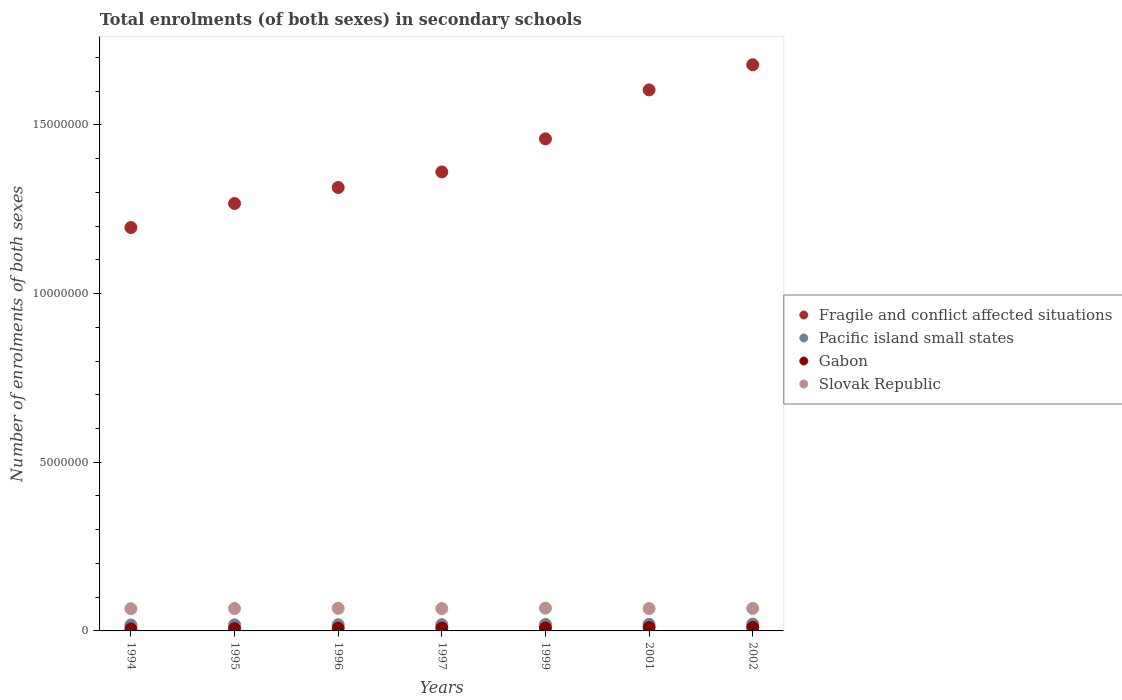What is the number of enrolments in secondary schools in Gabon in 1999?
Make the answer very short. 8.65e+04. Across all years, what is the maximum number of enrolments in secondary schools in Pacific island small states?
Your answer should be very brief. 2.03e+05. Across all years, what is the minimum number of enrolments in secondary schools in Gabon?
Offer a very short reply. 5.94e+04. In which year was the number of enrolments in secondary schools in Gabon maximum?
Keep it short and to the point. 2002. In which year was the number of enrolments in secondary schools in Slovak Republic minimum?
Offer a very short reply. 1994. What is the total number of enrolments in secondary schools in Pacific island small states in the graph?
Your response must be concise. 1.32e+06. What is the difference between the number of enrolments in secondary schools in Pacific island small states in 1997 and that in 2002?
Make the answer very short. -1.80e+04. What is the difference between the number of enrolments in secondary schools in Fragile and conflict affected situations in 1994 and the number of enrolments in secondary schools in Pacific island small states in 1997?
Provide a short and direct response. 1.18e+07. What is the average number of enrolments in secondary schools in Gabon per year?
Your answer should be very brief. 8.32e+04. In the year 2001, what is the difference between the number of enrolments in secondary schools in Pacific island small states and number of enrolments in secondary schools in Slovak Republic?
Provide a succinct answer. -4.69e+05. In how many years, is the number of enrolments in secondary schools in Slovak Republic greater than 2000000?
Keep it short and to the point. 0. What is the ratio of the number of enrolments in secondary schools in Pacific island small states in 1997 to that in 1999?
Make the answer very short. 0.96. What is the difference between the highest and the second highest number of enrolments in secondary schools in Pacific island small states?
Your answer should be very brief. 8784.14. What is the difference between the highest and the lowest number of enrolments in secondary schools in Gabon?
Give a very brief answer. 4.57e+04. In how many years, is the number of enrolments in secondary schools in Pacific island small states greater than the average number of enrolments in secondary schools in Pacific island small states taken over all years?
Your answer should be very brief. 3. Is it the case that in every year, the sum of the number of enrolments in secondary schools in Pacific island small states and number of enrolments in secondary schools in Slovak Republic  is greater than the number of enrolments in secondary schools in Gabon?
Make the answer very short. Yes. Does the number of enrolments in secondary schools in Pacific island small states monotonically increase over the years?
Provide a succinct answer. Yes. Is the number of enrolments in secondary schools in Pacific island small states strictly greater than the number of enrolments in secondary schools in Gabon over the years?
Offer a terse response. Yes. How many years are there in the graph?
Offer a very short reply. 7. Does the graph contain grids?
Keep it short and to the point. No. What is the title of the graph?
Your answer should be very brief. Total enrolments (of both sexes) in secondary schools. Does "Turks and Caicos Islands" appear as one of the legend labels in the graph?
Offer a terse response. No. What is the label or title of the Y-axis?
Make the answer very short. Number of enrolments of both sexes. What is the Number of enrolments of both sexes of Fragile and conflict affected situations in 1994?
Offer a terse response. 1.20e+07. What is the Number of enrolments of both sexes of Pacific island small states in 1994?
Provide a short and direct response. 1.76e+05. What is the Number of enrolments of both sexes in Gabon in 1994?
Offer a terse response. 5.94e+04. What is the Number of enrolments of both sexes of Slovak Republic in 1994?
Ensure brevity in your answer.  6.58e+05. What is the Number of enrolments of both sexes in Fragile and conflict affected situations in 1995?
Keep it short and to the point. 1.27e+07. What is the Number of enrolments of both sexes in Pacific island small states in 1995?
Your response must be concise. 1.80e+05. What is the Number of enrolments of both sexes in Gabon in 1995?
Make the answer very short. 6.57e+04. What is the Number of enrolments of both sexes in Slovak Republic in 1995?
Make the answer very short. 6.64e+05. What is the Number of enrolments of both sexes of Fragile and conflict affected situations in 1996?
Give a very brief answer. 1.31e+07. What is the Number of enrolments of both sexes in Pacific island small states in 1996?
Ensure brevity in your answer.  1.83e+05. What is the Number of enrolments of both sexes of Gabon in 1996?
Provide a succinct answer. 8.06e+04. What is the Number of enrolments of both sexes of Slovak Republic in 1996?
Offer a very short reply. 6.70e+05. What is the Number of enrolments of both sexes in Fragile and conflict affected situations in 1997?
Keep it short and to the point. 1.36e+07. What is the Number of enrolments of both sexes in Pacific island small states in 1997?
Ensure brevity in your answer.  1.85e+05. What is the Number of enrolments of both sexes of Gabon in 1997?
Provide a succinct answer. 8.42e+04. What is the Number of enrolments of both sexes in Slovak Republic in 1997?
Give a very brief answer. 6.63e+05. What is the Number of enrolments of both sexes of Fragile and conflict affected situations in 1999?
Your answer should be very brief. 1.46e+07. What is the Number of enrolments of both sexes of Pacific island small states in 1999?
Your answer should be compact. 1.93e+05. What is the Number of enrolments of both sexes in Gabon in 1999?
Provide a short and direct response. 8.65e+04. What is the Number of enrolments of both sexes in Slovak Republic in 1999?
Keep it short and to the point. 6.74e+05. What is the Number of enrolments of both sexes in Fragile and conflict affected situations in 2001?
Your response must be concise. 1.60e+07. What is the Number of enrolments of both sexes in Pacific island small states in 2001?
Offer a terse response. 1.94e+05. What is the Number of enrolments of both sexes of Gabon in 2001?
Ensure brevity in your answer.  1.01e+05. What is the Number of enrolments of both sexes in Slovak Republic in 2001?
Your answer should be very brief. 6.64e+05. What is the Number of enrolments of both sexes in Fragile and conflict affected situations in 2002?
Your answer should be very brief. 1.68e+07. What is the Number of enrolments of both sexes of Pacific island small states in 2002?
Your response must be concise. 2.03e+05. What is the Number of enrolments of both sexes of Gabon in 2002?
Offer a terse response. 1.05e+05. What is the Number of enrolments of both sexes in Slovak Republic in 2002?
Your answer should be compact. 6.66e+05. Across all years, what is the maximum Number of enrolments of both sexes of Fragile and conflict affected situations?
Keep it short and to the point. 1.68e+07. Across all years, what is the maximum Number of enrolments of both sexes in Pacific island small states?
Offer a terse response. 2.03e+05. Across all years, what is the maximum Number of enrolments of both sexes of Gabon?
Ensure brevity in your answer.  1.05e+05. Across all years, what is the maximum Number of enrolments of both sexes of Slovak Republic?
Provide a short and direct response. 6.74e+05. Across all years, what is the minimum Number of enrolments of both sexes in Fragile and conflict affected situations?
Provide a short and direct response. 1.20e+07. Across all years, what is the minimum Number of enrolments of both sexes in Pacific island small states?
Keep it short and to the point. 1.76e+05. Across all years, what is the minimum Number of enrolments of both sexes of Gabon?
Your response must be concise. 5.94e+04. Across all years, what is the minimum Number of enrolments of both sexes in Slovak Republic?
Your answer should be compact. 6.58e+05. What is the total Number of enrolments of both sexes in Fragile and conflict affected situations in the graph?
Your answer should be compact. 9.88e+07. What is the total Number of enrolments of both sexes of Pacific island small states in the graph?
Give a very brief answer. 1.32e+06. What is the total Number of enrolments of both sexes of Gabon in the graph?
Make the answer very short. 5.82e+05. What is the total Number of enrolments of both sexes of Slovak Republic in the graph?
Your response must be concise. 4.66e+06. What is the difference between the Number of enrolments of both sexes of Fragile and conflict affected situations in 1994 and that in 1995?
Ensure brevity in your answer.  -7.12e+05. What is the difference between the Number of enrolments of both sexes of Pacific island small states in 1994 and that in 1995?
Your answer should be very brief. -4002.09. What is the difference between the Number of enrolments of both sexes of Gabon in 1994 and that in 1995?
Offer a terse response. -6276. What is the difference between the Number of enrolments of both sexes of Slovak Republic in 1994 and that in 1995?
Make the answer very short. -5419. What is the difference between the Number of enrolments of both sexes in Fragile and conflict affected situations in 1994 and that in 1996?
Make the answer very short. -1.19e+06. What is the difference between the Number of enrolments of both sexes of Pacific island small states in 1994 and that in 1996?
Provide a succinct answer. -6209.23. What is the difference between the Number of enrolments of both sexes in Gabon in 1994 and that in 1996?
Offer a terse response. -2.11e+04. What is the difference between the Number of enrolments of both sexes in Slovak Republic in 1994 and that in 1996?
Offer a terse response. -1.17e+04. What is the difference between the Number of enrolments of both sexes of Fragile and conflict affected situations in 1994 and that in 1997?
Your response must be concise. -1.65e+06. What is the difference between the Number of enrolments of both sexes of Pacific island small states in 1994 and that in 1997?
Your answer should be compact. -8833.88. What is the difference between the Number of enrolments of both sexes of Gabon in 1994 and that in 1997?
Keep it short and to the point. -2.47e+04. What is the difference between the Number of enrolments of both sexes of Slovak Republic in 1994 and that in 1997?
Your answer should be compact. -4668. What is the difference between the Number of enrolments of both sexes of Fragile and conflict affected situations in 1994 and that in 1999?
Your answer should be very brief. -2.63e+06. What is the difference between the Number of enrolments of both sexes of Pacific island small states in 1994 and that in 1999?
Your response must be concise. -1.61e+04. What is the difference between the Number of enrolments of both sexes of Gabon in 1994 and that in 1999?
Offer a terse response. -2.71e+04. What is the difference between the Number of enrolments of both sexes in Slovak Republic in 1994 and that in 1999?
Offer a very short reply. -1.62e+04. What is the difference between the Number of enrolments of both sexes in Fragile and conflict affected situations in 1994 and that in 2001?
Your answer should be compact. -4.08e+06. What is the difference between the Number of enrolments of both sexes of Pacific island small states in 1994 and that in 2001?
Ensure brevity in your answer.  -1.80e+04. What is the difference between the Number of enrolments of both sexes of Gabon in 1994 and that in 2001?
Keep it short and to the point. -4.13e+04. What is the difference between the Number of enrolments of both sexes in Slovak Republic in 1994 and that in 2001?
Provide a succinct answer. -5327. What is the difference between the Number of enrolments of both sexes of Fragile and conflict affected situations in 1994 and that in 2002?
Your answer should be compact. -4.82e+06. What is the difference between the Number of enrolments of both sexes of Pacific island small states in 1994 and that in 2002?
Provide a short and direct response. -2.68e+04. What is the difference between the Number of enrolments of both sexes of Gabon in 1994 and that in 2002?
Provide a short and direct response. -4.57e+04. What is the difference between the Number of enrolments of both sexes of Slovak Republic in 1994 and that in 2002?
Your response must be concise. -8010. What is the difference between the Number of enrolments of both sexes of Fragile and conflict affected situations in 1995 and that in 1996?
Provide a succinct answer. -4.74e+05. What is the difference between the Number of enrolments of both sexes of Pacific island small states in 1995 and that in 1996?
Your answer should be very brief. -2207.14. What is the difference between the Number of enrolments of both sexes of Gabon in 1995 and that in 1996?
Your answer should be very brief. -1.48e+04. What is the difference between the Number of enrolments of both sexes of Slovak Republic in 1995 and that in 1996?
Provide a succinct answer. -6251. What is the difference between the Number of enrolments of both sexes of Fragile and conflict affected situations in 1995 and that in 1997?
Offer a very short reply. -9.36e+05. What is the difference between the Number of enrolments of both sexes of Pacific island small states in 1995 and that in 1997?
Make the answer very short. -4831.78. What is the difference between the Number of enrolments of both sexes in Gabon in 1995 and that in 1997?
Give a very brief answer. -1.84e+04. What is the difference between the Number of enrolments of both sexes in Slovak Republic in 1995 and that in 1997?
Your answer should be very brief. 751. What is the difference between the Number of enrolments of both sexes of Fragile and conflict affected situations in 1995 and that in 1999?
Your answer should be very brief. -1.92e+06. What is the difference between the Number of enrolments of both sexes in Pacific island small states in 1995 and that in 1999?
Your answer should be very brief. -1.21e+04. What is the difference between the Number of enrolments of both sexes in Gabon in 1995 and that in 1999?
Offer a terse response. -2.08e+04. What is the difference between the Number of enrolments of both sexes of Slovak Republic in 1995 and that in 1999?
Ensure brevity in your answer.  -1.08e+04. What is the difference between the Number of enrolments of both sexes in Fragile and conflict affected situations in 1995 and that in 2001?
Your response must be concise. -3.37e+06. What is the difference between the Number of enrolments of both sexes in Pacific island small states in 1995 and that in 2001?
Provide a succinct answer. -1.40e+04. What is the difference between the Number of enrolments of both sexes of Gabon in 1995 and that in 2001?
Give a very brief answer. -3.50e+04. What is the difference between the Number of enrolments of both sexes of Slovak Republic in 1995 and that in 2001?
Give a very brief answer. 92. What is the difference between the Number of enrolments of both sexes in Fragile and conflict affected situations in 1995 and that in 2002?
Provide a short and direct response. -4.11e+06. What is the difference between the Number of enrolments of both sexes in Pacific island small states in 1995 and that in 2002?
Your answer should be compact. -2.28e+04. What is the difference between the Number of enrolments of both sexes in Gabon in 1995 and that in 2002?
Provide a succinct answer. -3.95e+04. What is the difference between the Number of enrolments of both sexes of Slovak Republic in 1995 and that in 2002?
Give a very brief answer. -2591. What is the difference between the Number of enrolments of both sexes in Fragile and conflict affected situations in 1996 and that in 1997?
Keep it short and to the point. -4.62e+05. What is the difference between the Number of enrolments of both sexes in Pacific island small states in 1996 and that in 1997?
Your response must be concise. -2624.64. What is the difference between the Number of enrolments of both sexes in Gabon in 1996 and that in 1997?
Give a very brief answer. -3603. What is the difference between the Number of enrolments of both sexes in Slovak Republic in 1996 and that in 1997?
Make the answer very short. 7002. What is the difference between the Number of enrolments of both sexes of Fragile and conflict affected situations in 1996 and that in 1999?
Provide a succinct answer. -1.44e+06. What is the difference between the Number of enrolments of both sexes in Pacific island small states in 1996 and that in 1999?
Offer a very short reply. -9932.52. What is the difference between the Number of enrolments of both sexes in Gabon in 1996 and that in 1999?
Keep it short and to the point. -5991. What is the difference between the Number of enrolments of both sexes in Slovak Republic in 1996 and that in 1999?
Your answer should be compact. -4507. What is the difference between the Number of enrolments of both sexes in Fragile and conflict affected situations in 1996 and that in 2001?
Your response must be concise. -2.89e+06. What is the difference between the Number of enrolments of both sexes in Pacific island small states in 1996 and that in 2001?
Offer a very short reply. -1.18e+04. What is the difference between the Number of enrolments of both sexes of Gabon in 1996 and that in 2001?
Keep it short and to the point. -2.02e+04. What is the difference between the Number of enrolments of both sexes in Slovak Republic in 1996 and that in 2001?
Offer a terse response. 6343. What is the difference between the Number of enrolments of both sexes in Fragile and conflict affected situations in 1996 and that in 2002?
Offer a very short reply. -3.64e+06. What is the difference between the Number of enrolments of both sexes in Pacific island small states in 1996 and that in 2002?
Give a very brief answer. -2.06e+04. What is the difference between the Number of enrolments of both sexes of Gabon in 1996 and that in 2002?
Keep it short and to the point. -2.46e+04. What is the difference between the Number of enrolments of both sexes of Slovak Republic in 1996 and that in 2002?
Provide a succinct answer. 3660. What is the difference between the Number of enrolments of both sexes in Fragile and conflict affected situations in 1997 and that in 1999?
Your answer should be very brief. -9.81e+05. What is the difference between the Number of enrolments of both sexes in Pacific island small states in 1997 and that in 1999?
Provide a short and direct response. -7307.88. What is the difference between the Number of enrolments of both sexes of Gabon in 1997 and that in 1999?
Give a very brief answer. -2388. What is the difference between the Number of enrolments of both sexes in Slovak Republic in 1997 and that in 1999?
Provide a short and direct response. -1.15e+04. What is the difference between the Number of enrolments of both sexes in Fragile and conflict affected situations in 1997 and that in 2001?
Offer a very short reply. -2.43e+06. What is the difference between the Number of enrolments of both sexes in Pacific island small states in 1997 and that in 2001?
Provide a short and direct response. -9185.97. What is the difference between the Number of enrolments of both sexes in Gabon in 1997 and that in 2001?
Ensure brevity in your answer.  -1.66e+04. What is the difference between the Number of enrolments of both sexes in Slovak Republic in 1997 and that in 2001?
Your response must be concise. -659. What is the difference between the Number of enrolments of both sexes in Fragile and conflict affected situations in 1997 and that in 2002?
Offer a terse response. -3.18e+06. What is the difference between the Number of enrolments of both sexes in Pacific island small states in 1997 and that in 2002?
Offer a terse response. -1.80e+04. What is the difference between the Number of enrolments of both sexes in Gabon in 1997 and that in 2002?
Keep it short and to the point. -2.10e+04. What is the difference between the Number of enrolments of both sexes in Slovak Republic in 1997 and that in 2002?
Keep it short and to the point. -3342. What is the difference between the Number of enrolments of both sexes of Fragile and conflict affected situations in 1999 and that in 2001?
Offer a terse response. -1.45e+06. What is the difference between the Number of enrolments of both sexes of Pacific island small states in 1999 and that in 2001?
Make the answer very short. -1878.09. What is the difference between the Number of enrolments of both sexes of Gabon in 1999 and that in 2001?
Give a very brief answer. -1.42e+04. What is the difference between the Number of enrolments of both sexes in Slovak Republic in 1999 and that in 2001?
Give a very brief answer. 1.08e+04. What is the difference between the Number of enrolments of both sexes of Fragile and conflict affected situations in 1999 and that in 2002?
Your answer should be compact. -2.20e+06. What is the difference between the Number of enrolments of both sexes of Pacific island small states in 1999 and that in 2002?
Keep it short and to the point. -1.07e+04. What is the difference between the Number of enrolments of both sexes in Gabon in 1999 and that in 2002?
Your answer should be very brief. -1.86e+04. What is the difference between the Number of enrolments of both sexes of Slovak Republic in 1999 and that in 2002?
Provide a succinct answer. 8167. What is the difference between the Number of enrolments of both sexes in Fragile and conflict affected situations in 2001 and that in 2002?
Ensure brevity in your answer.  -7.44e+05. What is the difference between the Number of enrolments of both sexes in Pacific island small states in 2001 and that in 2002?
Offer a terse response. -8784.14. What is the difference between the Number of enrolments of both sexes in Gabon in 2001 and that in 2002?
Provide a succinct answer. -4473. What is the difference between the Number of enrolments of both sexes in Slovak Republic in 2001 and that in 2002?
Make the answer very short. -2683. What is the difference between the Number of enrolments of both sexes in Fragile and conflict affected situations in 1994 and the Number of enrolments of both sexes in Pacific island small states in 1995?
Make the answer very short. 1.18e+07. What is the difference between the Number of enrolments of both sexes in Fragile and conflict affected situations in 1994 and the Number of enrolments of both sexes in Gabon in 1995?
Offer a very short reply. 1.19e+07. What is the difference between the Number of enrolments of both sexes in Fragile and conflict affected situations in 1994 and the Number of enrolments of both sexes in Slovak Republic in 1995?
Provide a succinct answer. 1.13e+07. What is the difference between the Number of enrolments of both sexes of Pacific island small states in 1994 and the Number of enrolments of both sexes of Gabon in 1995?
Keep it short and to the point. 1.11e+05. What is the difference between the Number of enrolments of both sexes in Pacific island small states in 1994 and the Number of enrolments of both sexes in Slovak Republic in 1995?
Offer a very short reply. -4.87e+05. What is the difference between the Number of enrolments of both sexes of Gabon in 1994 and the Number of enrolments of both sexes of Slovak Republic in 1995?
Your response must be concise. -6.04e+05. What is the difference between the Number of enrolments of both sexes in Fragile and conflict affected situations in 1994 and the Number of enrolments of both sexes in Pacific island small states in 1996?
Offer a very short reply. 1.18e+07. What is the difference between the Number of enrolments of both sexes of Fragile and conflict affected situations in 1994 and the Number of enrolments of both sexes of Gabon in 1996?
Your response must be concise. 1.19e+07. What is the difference between the Number of enrolments of both sexes of Fragile and conflict affected situations in 1994 and the Number of enrolments of both sexes of Slovak Republic in 1996?
Your answer should be compact. 1.13e+07. What is the difference between the Number of enrolments of both sexes of Pacific island small states in 1994 and the Number of enrolments of both sexes of Gabon in 1996?
Keep it short and to the point. 9.59e+04. What is the difference between the Number of enrolments of both sexes of Pacific island small states in 1994 and the Number of enrolments of both sexes of Slovak Republic in 1996?
Give a very brief answer. -4.93e+05. What is the difference between the Number of enrolments of both sexes of Gabon in 1994 and the Number of enrolments of both sexes of Slovak Republic in 1996?
Ensure brevity in your answer.  -6.10e+05. What is the difference between the Number of enrolments of both sexes of Fragile and conflict affected situations in 1994 and the Number of enrolments of both sexes of Pacific island small states in 1997?
Your response must be concise. 1.18e+07. What is the difference between the Number of enrolments of both sexes in Fragile and conflict affected situations in 1994 and the Number of enrolments of both sexes in Gabon in 1997?
Provide a short and direct response. 1.19e+07. What is the difference between the Number of enrolments of both sexes in Fragile and conflict affected situations in 1994 and the Number of enrolments of both sexes in Slovak Republic in 1997?
Offer a very short reply. 1.13e+07. What is the difference between the Number of enrolments of both sexes of Pacific island small states in 1994 and the Number of enrolments of both sexes of Gabon in 1997?
Ensure brevity in your answer.  9.23e+04. What is the difference between the Number of enrolments of both sexes in Pacific island small states in 1994 and the Number of enrolments of both sexes in Slovak Republic in 1997?
Your answer should be very brief. -4.86e+05. What is the difference between the Number of enrolments of both sexes in Gabon in 1994 and the Number of enrolments of both sexes in Slovak Republic in 1997?
Your response must be concise. -6.03e+05. What is the difference between the Number of enrolments of both sexes in Fragile and conflict affected situations in 1994 and the Number of enrolments of both sexes in Pacific island small states in 1999?
Give a very brief answer. 1.18e+07. What is the difference between the Number of enrolments of both sexes of Fragile and conflict affected situations in 1994 and the Number of enrolments of both sexes of Gabon in 1999?
Your response must be concise. 1.19e+07. What is the difference between the Number of enrolments of both sexes of Fragile and conflict affected situations in 1994 and the Number of enrolments of both sexes of Slovak Republic in 1999?
Your response must be concise. 1.13e+07. What is the difference between the Number of enrolments of both sexes of Pacific island small states in 1994 and the Number of enrolments of both sexes of Gabon in 1999?
Give a very brief answer. 8.99e+04. What is the difference between the Number of enrolments of both sexes in Pacific island small states in 1994 and the Number of enrolments of both sexes in Slovak Republic in 1999?
Your response must be concise. -4.98e+05. What is the difference between the Number of enrolments of both sexes in Gabon in 1994 and the Number of enrolments of both sexes in Slovak Republic in 1999?
Your response must be concise. -6.15e+05. What is the difference between the Number of enrolments of both sexes of Fragile and conflict affected situations in 1994 and the Number of enrolments of both sexes of Pacific island small states in 2001?
Provide a succinct answer. 1.18e+07. What is the difference between the Number of enrolments of both sexes in Fragile and conflict affected situations in 1994 and the Number of enrolments of both sexes in Gabon in 2001?
Keep it short and to the point. 1.19e+07. What is the difference between the Number of enrolments of both sexes in Fragile and conflict affected situations in 1994 and the Number of enrolments of both sexes in Slovak Republic in 2001?
Your response must be concise. 1.13e+07. What is the difference between the Number of enrolments of both sexes of Pacific island small states in 1994 and the Number of enrolments of both sexes of Gabon in 2001?
Give a very brief answer. 7.57e+04. What is the difference between the Number of enrolments of both sexes of Pacific island small states in 1994 and the Number of enrolments of both sexes of Slovak Republic in 2001?
Your response must be concise. -4.87e+05. What is the difference between the Number of enrolments of both sexes in Gabon in 1994 and the Number of enrolments of both sexes in Slovak Republic in 2001?
Make the answer very short. -6.04e+05. What is the difference between the Number of enrolments of both sexes of Fragile and conflict affected situations in 1994 and the Number of enrolments of both sexes of Pacific island small states in 2002?
Offer a very short reply. 1.18e+07. What is the difference between the Number of enrolments of both sexes in Fragile and conflict affected situations in 1994 and the Number of enrolments of both sexes in Gabon in 2002?
Your response must be concise. 1.19e+07. What is the difference between the Number of enrolments of both sexes of Fragile and conflict affected situations in 1994 and the Number of enrolments of both sexes of Slovak Republic in 2002?
Make the answer very short. 1.13e+07. What is the difference between the Number of enrolments of both sexes in Pacific island small states in 1994 and the Number of enrolments of both sexes in Gabon in 2002?
Your answer should be very brief. 7.13e+04. What is the difference between the Number of enrolments of both sexes of Pacific island small states in 1994 and the Number of enrolments of both sexes of Slovak Republic in 2002?
Your response must be concise. -4.90e+05. What is the difference between the Number of enrolments of both sexes of Gabon in 1994 and the Number of enrolments of both sexes of Slovak Republic in 2002?
Offer a very short reply. -6.07e+05. What is the difference between the Number of enrolments of both sexes of Fragile and conflict affected situations in 1995 and the Number of enrolments of both sexes of Pacific island small states in 1996?
Your answer should be very brief. 1.25e+07. What is the difference between the Number of enrolments of both sexes of Fragile and conflict affected situations in 1995 and the Number of enrolments of both sexes of Gabon in 1996?
Offer a terse response. 1.26e+07. What is the difference between the Number of enrolments of both sexes in Fragile and conflict affected situations in 1995 and the Number of enrolments of both sexes in Slovak Republic in 1996?
Provide a short and direct response. 1.20e+07. What is the difference between the Number of enrolments of both sexes of Pacific island small states in 1995 and the Number of enrolments of both sexes of Gabon in 1996?
Provide a short and direct response. 9.99e+04. What is the difference between the Number of enrolments of both sexes in Pacific island small states in 1995 and the Number of enrolments of both sexes in Slovak Republic in 1996?
Keep it short and to the point. -4.89e+05. What is the difference between the Number of enrolments of both sexes of Gabon in 1995 and the Number of enrolments of both sexes of Slovak Republic in 1996?
Provide a succinct answer. -6.04e+05. What is the difference between the Number of enrolments of both sexes in Fragile and conflict affected situations in 1995 and the Number of enrolments of both sexes in Pacific island small states in 1997?
Offer a very short reply. 1.25e+07. What is the difference between the Number of enrolments of both sexes of Fragile and conflict affected situations in 1995 and the Number of enrolments of both sexes of Gabon in 1997?
Ensure brevity in your answer.  1.26e+07. What is the difference between the Number of enrolments of both sexes in Fragile and conflict affected situations in 1995 and the Number of enrolments of both sexes in Slovak Republic in 1997?
Your answer should be very brief. 1.20e+07. What is the difference between the Number of enrolments of both sexes of Pacific island small states in 1995 and the Number of enrolments of both sexes of Gabon in 1997?
Keep it short and to the point. 9.63e+04. What is the difference between the Number of enrolments of both sexes of Pacific island small states in 1995 and the Number of enrolments of both sexes of Slovak Republic in 1997?
Ensure brevity in your answer.  -4.82e+05. What is the difference between the Number of enrolments of both sexes of Gabon in 1995 and the Number of enrolments of both sexes of Slovak Republic in 1997?
Your response must be concise. -5.97e+05. What is the difference between the Number of enrolments of both sexes in Fragile and conflict affected situations in 1995 and the Number of enrolments of both sexes in Pacific island small states in 1999?
Your response must be concise. 1.25e+07. What is the difference between the Number of enrolments of both sexes of Fragile and conflict affected situations in 1995 and the Number of enrolments of both sexes of Gabon in 1999?
Offer a very short reply. 1.26e+07. What is the difference between the Number of enrolments of both sexes of Fragile and conflict affected situations in 1995 and the Number of enrolments of both sexes of Slovak Republic in 1999?
Offer a very short reply. 1.20e+07. What is the difference between the Number of enrolments of both sexes of Pacific island small states in 1995 and the Number of enrolments of both sexes of Gabon in 1999?
Provide a succinct answer. 9.39e+04. What is the difference between the Number of enrolments of both sexes in Pacific island small states in 1995 and the Number of enrolments of both sexes in Slovak Republic in 1999?
Ensure brevity in your answer.  -4.94e+05. What is the difference between the Number of enrolments of both sexes in Gabon in 1995 and the Number of enrolments of both sexes in Slovak Republic in 1999?
Provide a short and direct response. -6.09e+05. What is the difference between the Number of enrolments of both sexes of Fragile and conflict affected situations in 1995 and the Number of enrolments of both sexes of Pacific island small states in 2001?
Ensure brevity in your answer.  1.25e+07. What is the difference between the Number of enrolments of both sexes of Fragile and conflict affected situations in 1995 and the Number of enrolments of both sexes of Gabon in 2001?
Your response must be concise. 1.26e+07. What is the difference between the Number of enrolments of both sexes in Fragile and conflict affected situations in 1995 and the Number of enrolments of both sexes in Slovak Republic in 2001?
Ensure brevity in your answer.  1.20e+07. What is the difference between the Number of enrolments of both sexes in Pacific island small states in 1995 and the Number of enrolments of both sexes in Gabon in 2001?
Provide a succinct answer. 7.97e+04. What is the difference between the Number of enrolments of both sexes of Pacific island small states in 1995 and the Number of enrolments of both sexes of Slovak Republic in 2001?
Your response must be concise. -4.83e+05. What is the difference between the Number of enrolments of both sexes in Gabon in 1995 and the Number of enrolments of both sexes in Slovak Republic in 2001?
Your answer should be compact. -5.98e+05. What is the difference between the Number of enrolments of both sexes of Fragile and conflict affected situations in 1995 and the Number of enrolments of both sexes of Pacific island small states in 2002?
Make the answer very short. 1.25e+07. What is the difference between the Number of enrolments of both sexes in Fragile and conflict affected situations in 1995 and the Number of enrolments of both sexes in Gabon in 2002?
Your answer should be compact. 1.26e+07. What is the difference between the Number of enrolments of both sexes in Fragile and conflict affected situations in 1995 and the Number of enrolments of both sexes in Slovak Republic in 2002?
Your answer should be compact. 1.20e+07. What is the difference between the Number of enrolments of both sexes of Pacific island small states in 1995 and the Number of enrolments of both sexes of Gabon in 2002?
Your response must be concise. 7.53e+04. What is the difference between the Number of enrolments of both sexes of Pacific island small states in 1995 and the Number of enrolments of both sexes of Slovak Republic in 2002?
Keep it short and to the point. -4.86e+05. What is the difference between the Number of enrolments of both sexes of Gabon in 1995 and the Number of enrolments of both sexes of Slovak Republic in 2002?
Offer a very short reply. -6.01e+05. What is the difference between the Number of enrolments of both sexes in Fragile and conflict affected situations in 1996 and the Number of enrolments of both sexes in Pacific island small states in 1997?
Provide a succinct answer. 1.30e+07. What is the difference between the Number of enrolments of both sexes in Fragile and conflict affected situations in 1996 and the Number of enrolments of both sexes in Gabon in 1997?
Keep it short and to the point. 1.31e+07. What is the difference between the Number of enrolments of both sexes of Fragile and conflict affected situations in 1996 and the Number of enrolments of both sexes of Slovak Republic in 1997?
Offer a terse response. 1.25e+07. What is the difference between the Number of enrolments of both sexes of Pacific island small states in 1996 and the Number of enrolments of both sexes of Gabon in 1997?
Your response must be concise. 9.85e+04. What is the difference between the Number of enrolments of both sexes of Pacific island small states in 1996 and the Number of enrolments of both sexes of Slovak Republic in 1997?
Give a very brief answer. -4.80e+05. What is the difference between the Number of enrolments of both sexes in Gabon in 1996 and the Number of enrolments of both sexes in Slovak Republic in 1997?
Offer a very short reply. -5.82e+05. What is the difference between the Number of enrolments of both sexes of Fragile and conflict affected situations in 1996 and the Number of enrolments of both sexes of Pacific island small states in 1999?
Ensure brevity in your answer.  1.30e+07. What is the difference between the Number of enrolments of both sexes in Fragile and conflict affected situations in 1996 and the Number of enrolments of both sexes in Gabon in 1999?
Provide a succinct answer. 1.31e+07. What is the difference between the Number of enrolments of both sexes in Fragile and conflict affected situations in 1996 and the Number of enrolments of both sexes in Slovak Republic in 1999?
Give a very brief answer. 1.25e+07. What is the difference between the Number of enrolments of both sexes of Pacific island small states in 1996 and the Number of enrolments of both sexes of Gabon in 1999?
Offer a very short reply. 9.61e+04. What is the difference between the Number of enrolments of both sexes of Pacific island small states in 1996 and the Number of enrolments of both sexes of Slovak Republic in 1999?
Your answer should be very brief. -4.92e+05. What is the difference between the Number of enrolments of both sexes in Gabon in 1996 and the Number of enrolments of both sexes in Slovak Republic in 1999?
Give a very brief answer. -5.94e+05. What is the difference between the Number of enrolments of both sexes in Fragile and conflict affected situations in 1996 and the Number of enrolments of both sexes in Pacific island small states in 2001?
Offer a terse response. 1.30e+07. What is the difference between the Number of enrolments of both sexes of Fragile and conflict affected situations in 1996 and the Number of enrolments of both sexes of Gabon in 2001?
Make the answer very short. 1.30e+07. What is the difference between the Number of enrolments of both sexes in Fragile and conflict affected situations in 1996 and the Number of enrolments of both sexes in Slovak Republic in 2001?
Offer a very short reply. 1.25e+07. What is the difference between the Number of enrolments of both sexes in Pacific island small states in 1996 and the Number of enrolments of both sexes in Gabon in 2001?
Make the answer very short. 8.19e+04. What is the difference between the Number of enrolments of both sexes of Pacific island small states in 1996 and the Number of enrolments of both sexes of Slovak Republic in 2001?
Keep it short and to the point. -4.81e+05. What is the difference between the Number of enrolments of both sexes of Gabon in 1996 and the Number of enrolments of both sexes of Slovak Republic in 2001?
Ensure brevity in your answer.  -5.83e+05. What is the difference between the Number of enrolments of both sexes in Fragile and conflict affected situations in 1996 and the Number of enrolments of both sexes in Pacific island small states in 2002?
Provide a short and direct response. 1.29e+07. What is the difference between the Number of enrolments of both sexes of Fragile and conflict affected situations in 1996 and the Number of enrolments of both sexes of Gabon in 2002?
Offer a terse response. 1.30e+07. What is the difference between the Number of enrolments of both sexes in Fragile and conflict affected situations in 1996 and the Number of enrolments of both sexes in Slovak Republic in 2002?
Offer a very short reply. 1.25e+07. What is the difference between the Number of enrolments of both sexes in Pacific island small states in 1996 and the Number of enrolments of both sexes in Gabon in 2002?
Make the answer very short. 7.75e+04. What is the difference between the Number of enrolments of both sexes in Pacific island small states in 1996 and the Number of enrolments of both sexes in Slovak Republic in 2002?
Offer a very short reply. -4.84e+05. What is the difference between the Number of enrolments of both sexes of Gabon in 1996 and the Number of enrolments of both sexes of Slovak Republic in 2002?
Your answer should be very brief. -5.86e+05. What is the difference between the Number of enrolments of both sexes in Fragile and conflict affected situations in 1997 and the Number of enrolments of both sexes in Pacific island small states in 1999?
Your answer should be very brief. 1.34e+07. What is the difference between the Number of enrolments of both sexes of Fragile and conflict affected situations in 1997 and the Number of enrolments of both sexes of Gabon in 1999?
Ensure brevity in your answer.  1.35e+07. What is the difference between the Number of enrolments of both sexes of Fragile and conflict affected situations in 1997 and the Number of enrolments of both sexes of Slovak Republic in 1999?
Make the answer very short. 1.29e+07. What is the difference between the Number of enrolments of both sexes in Pacific island small states in 1997 and the Number of enrolments of both sexes in Gabon in 1999?
Offer a terse response. 9.87e+04. What is the difference between the Number of enrolments of both sexes of Pacific island small states in 1997 and the Number of enrolments of both sexes of Slovak Republic in 1999?
Ensure brevity in your answer.  -4.89e+05. What is the difference between the Number of enrolments of both sexes in Gabon in 1997 and the Number of enrolments of both sexes in Slovak Republic in 1999?
Your answer should be compact. -5.90e+05. What is the difference between the Number of enrolments of both sexes in Fragile and conflict affected situations in 1997 and the Number of enrolments of both sexes in Pacific island small states in 2001?
Offer a very short reply. 1.34e+07. What is the difference between the Number of enrolments of both sexes of Fragile and conflict affected situations in 1997 and the Number of enrolments of both sexes of Gabon in 2001?
Give a very brief answer. 1.35e+07. What is the difference between the Number of enrolments of both sexes of Fragile and conflict affected situations in 1997 and the Number of enrolments of both sexes of Slovak Republic in 2001?
Give a very brief answer. 1.29e+07. What is the difference between the Number of enrolments of both sexes in Pacific island small states in 1997 and the Number of enrolments of both sexes in Gabon in 2001?
Give a very brief answer. 8.46e+04. What is the difference between the Number of enrolments of both sexes of Pacific island small states in 1997 and the Number of enrolments of both sexes of Slovak Republic in 2001?
Keep it short and to the point. -4.78e+05. What is the difference between the Number of enrolments of both sexes of Gabon in 1997 and the Number of enrolments of both sexes of Slovak Republic in 2001?
Ensure brevity in your answer.  -5.79e+05. What is the difference between the Number of enrolments of both sexes in Fragile and conflict affected situations in 1997 and the Number of enrolments of both sexes in Pacific island small states in 2002?
Provide a short and direct response. 1.34e+07. What is the difference between the Number of enrolments of both sexes in Fragile and conflict affected situations in 1997 and the Number of enrolments of both sexes in Gabon in 2002?
Your answer should be compact. 1.35e+07. What is the difference between the Number of enrolments of both sexes of Fragile and conflict affected situations in 1997 and the Number of enrolments of both sexes of Slovak Republic in 2002?
Ensure brevity in your answer.  1.29e+07. What is the difference between the Number of enrolments of both sexes in Pacific island small states in 1997 and the Number of enrolments of both sexes in Gabon in 2002?
Your response must be concise. 8.01e+04. What is the difference between the Number of enrolments of both sexes of Pacific island small states in 1997 and the Number of enrolments of both sexes of Slovak Republic in 2002?
Give a very brief answer. -4.81e+05. What is the difference between the Number of enrolments of both sexes of Gabon in 1997 and the Number of enrolments of both sexes of Slovak Republic in 2002?
Offer a terse response. -5.82e+05. What is the difference between the Number of enrolments of both sexes of Fragile and conflict affected situations in 1999 and the Number of enrolments of both sexes of Pacific island small states in 2001?
Provide a succinct answer. 1.44e+07. What is the difference between the Number of enrolments of both sexes of Fragile and conflict affected situations in 1999 and the Number of enrolments of both sexes of Gabon in 2001?
Give a very brief answer. 1.45e+07. What is the difference between the Number of enrolments of both sexes of Fragile and conflict affected situations in 1999 and the Number of enrolments of both sexes of Slovak Republic in 2001?
Your answer should be compact. 1.39e+07. What is the difference between the Number of enrolments of both sexes of Pacific island small states in 1999 and the Number of enrolments of both sexes of Gabon in 2001?
Offer a terse response. 9.19e+04. What is the difference between the Number of enrolments of both sexes of Pacific island small states in 1999 and the Number of enrolments of both sexes of Slovak Republic in 2001?
Your answer should be very brief. -4.71e+05. What is the difference between the Number of enrolments of both sexes in Gabon in 1999 and the Number of enrolments of both sexes in Slovak Republic in 2001?
Your answer should be very brief. -5.77e+05. What is the difference between the Number of enrolments of both sexes in Fragile and conflict affected situations in 1999 and the Number of enrolments of both sexes in Pacific island small states in 2002?
Your answer should be very brief. 1.44e+07. What is the difference between the Number of enrolments of both sexes in Fragile and conflict affected situations in 1999 and the Number of enrolments of both sexes in Gabon in 2002?
Your response must be concise. 1.45e+07. What is the difference between the Number of enrolments of both sexes of Fragile and conflict affected situations in 1999 and the Number of enrolments of both sexes of Slovak Republic in 2002?
Provide a short and direct response. 1.39e+07. What is the difference between the Number of enrolments of both sexes in Pacific island small states in 1999 and the Number of enrolments of both sexes in Gabon in 2002?
Keep it short and to the point. 8.74e+04. What is the difference between the Number of enrolments of both sexes of Pacific island small states in 1999 and the Number of enrolments of both sexes of Slovak Republic in 2002?
Keep it short and to the point. -4.74e+05. What is the difference between the Number of enrolments of both sexes of Gabon in 1999 and the Number of enrolments of both sexes of Slovak Republic in 2002?
Keep it short and to the point. -5.80e+05. What is the difference between the Number of enrolments of both sexes of Fragile and conflict affected situations in 2001 and the Number of enrolments of both sexes of Pacific island small states in 2002?
Make the answer very short. 1.58e+07. What is the difference between the Number of enrolments of both sexes of Fragile and conflict affected situations in 2001 and the Number of enrolments of both sexes of Gabon in 2002?
Give a very brief answer. 1.59e+07. What is the difference between the Number of enrolments of both sexes in Fragile and conflict affected situations in 2001 and the Number of enrolments of both sexes in Slovak Republic in 2002?
Give a very brief answer. 1.54e+07. What is the difference between the Number of enrolments of both sexes in Pacific island small states in 2001 and the Number of enrolments of both sexes in Gabon in 2002?
Your response must be concise. 8.93e+04. What is the difference between the Number of enrolments of both sexes in Pacific island small states in 2001 and the Number of enrolments of both sexes in Slovak Republic in 2002?
Provide a short and direct response. -4.72e+05. What is the difference between the Number of enrolments of both sexes in Gabon in 2001 and the Number of enrolments of both sexes in Slovak Republic in 2002?
Give a very brief answer. -5.66e+05. What is the average Number of enrolments of both sexes in Fragile and conflict affected situations per year?
Make the answer very short. 1.41e+07. What is the average Number of enrolments of both sexes in Pacific island small states per year?
Ensure brevity in your answer.  1.88e+05. What is the average Number of enrolments of both sexes of Gabon per year?
Provide a succinct answer. 8.32e+04. What is the average Number of enrolments of both sexes in Slovak Republic per year?
Give a very brief answer. 6.66e+05. In the year 1994, what is the difference between the Number of enrolments of both sexes in Fragile and conflict affected situations and Number of enrolments of both sexes in Pacific island small states?
Your answer should be compact. 1.18e+07. In the year 1994, what is the difference between the Number of enrolments of both sexes of Fragile and conflict affected situations and Number of enrolments of both sexes of Gabon?
Your answer should be very brief. 1.19e+07. In the year 1994, what is the difference between the Number of enrolments of both sexes in Fragile and conflict affected situations and Number of enrolments of both sexes in Slovak Republic?
Ensure brevity in your answer.  1.13e+07. In the year 1994, what is the difference between the Number of enrolments of both sexes of Pacific island small states and Number of enrolments of both sexes of Gabon?
Ensure brevity in your answer.  1.17e+05. In the year 1994, what is the difference between the Number of enrolments of both sexes of Pacific island small states and Number of enrolments of both sexes of Slovak Republic?
Ensure brevity in your answer.  -4.82e+05. In the year 1994, what is the difference between the Number of enrolments of both sexes of Gabon and Number of enrolments of both sexes of Slovak Republic?
Your response must be concise. -5.99e+05. In the year 1995, what is the difference between the Number of enrolments of both sexes in Fragile and conflict affected situations and Number of enrolments of both sexes in Pacific island small states?
Provide a succinct answer. 1.25e+07. In the year 1995, what is the difference between the Number of enrolments of both sexes of Fragile and conflict affected situations and Number of enrolments of both sexes of Gabon?
Offer a terse response. 1.26e+07. In the year 1995, what is the difference between the Number of enrolments of both sexes in Fragile and conflict affected situations and Number of enrolments of both sexes in Slovak Republic?
Offer a terse response. 1.20e+07. In the year 1995, what is the difference between the Number of enrolments of both sexes of Pacific island small states and Number of enrolments of both sexes of Gabon?
Your response must be concise. 1.15e+05. In the year 1995, what is the difference between the Number of enrolments of both sexes in Pacific island small states and Number of enrolments of both sexes in Slovak Republic?
Your answer should be compact. -4.83e+05. In the year 1995, what is the difference between the Number of enrolments of both sexes of Gabon and Number of enrolments of both sexes of Slovak Republic?
Ensure brevity in your answer.  -5.98e+05. In the year 1996, what is the difference between the Number of enrolments of both sexes of Fragile and conflict affected situations and Number of enrolments of both sexes of Pacific island small states?
Your answer should be very brief. 1.30e+07. In the year 1996, what is the difference between the Number of enrolments of both sexes of Fragile and conflict affected situations and Number of enrolments of both sexes of Gabon?
Your answer should be compact. 1.31e+07. In the year 1996, what is the difference between the Number of enrolments of both sexes of Fragile and conflict affected situations and Number of enrolments of both sexes of Slovak Republic?
Give a very brief answer. 1.25e+07. In the year 1996, what is the difference between the Number of enrolments of both sexes of Pacific island small states and Number of enrolments of both sexes of Gabon?
Provide a short and direct response. 1.02e+05. In the year 1996, what is the difference between the Number of enrolments of both sexes in Pacific island small states and Number of enrolments of both sexes in Slovak Republic?
Provide a short and direct response. -4.87e+05. In the year 1996, what is the difference between the Number of enrolments of both sexes in Gabon and Number of enrolments of both sexes in Slovak Republic?
Give a very brief answer. -5.89e+05. In the year 1997, what is the difference between the Number of enrolments of both sexes in Fragile and conflict affected situations and Number of enrolments of both sexes in Pacific island small states?
Give a very brief answer. 1.34e+07. In the year 1997, what is the difference between the Number of enrolments of both sexes in Fragile and conflict affected situations and Number of enrolments of both sexes in Gabon?
Give a very brief answer. 1.35e+07. In the year 1997, what is the difference between the Number of enrolments of both sexes of Fragile and conflict affected situations and Number of enrolments of both sexes of Slovak Republic?
Give a very brief answer. 1.29e+07. In the year 1997, what is the difference between the Number of enrolments of both sexes of Pacific island small states and Number of enrolments of both sexes of Gabon?
Provide a succinct answer. 1.01e+05. In the year 1997, what is the difference between the Number of enrolments of both sexes of Pacific island small states and Number of enrolments of both sexes of Slovak Republic?
Offer a very short reply. -4.78e+05. In the year 1997, what is the difference between the Number of enrolments of both sexes in Gabon and Number of enrolments of both sexes in Slovak Republic?
Give a very brief answer. -5.79e+05. In the year 1999, what is the difference between the Number of enrolments of both sexes of Fragile and conflict affected situations and Number of enrolments of both sexes of Pacific island small states?
Provide a short and direct response. 1.44e+07. In the year 1999, what is the difference between the Number of enrolments of both sexes in Fragile and conflict affected situations and Number of enrolments of both sexes in Gabon?
Offer a very short reply. 1.45e+07. In the year 1999, what is the difference between the Number of enrolments of both sexes of Fragile and conflict affected situations and Number of enrolments of both sexes of Slovak Republic?
Your response must be concise. 1.39e+07. In the year 1999, what is the difference between the Number of enrolments of both sexes in Pacific island small states and Number of enrolments of both sexes in Gabon?
Your answer should be compact. 1.06e+05. In the year 1999, what is the difference between the Number of enrolments of both sexes of Pacific island small states and Number of enrolments of both sexes of Slovak Republic?
Make the answer very short. -4.82e+05. In the year 1999, what is the difference between the Number of enrolments of both sexes in Gabon and Number of enrolments of both sexes in Slovak Republic?
Provide a succinct answer. -5.88e+05. In the year 2001, what is the difference between the Number of enrolments of both sexes of Fragile and conflict affected situations and Number of enrolments of both sexes of Pacific island small states?
Keep it short and to the point. 1.58e+07. In the year 2001, what is the difference between the Number of enrolments of both sexes in Fragile and conflict affected situations and Number of enrolments of both sexes in Gabon?
Offer a terse response. 1.59e+07. In the year 2001, what is the difference between the Number of enrolments of both sexes of Fragile and conflict affected situations and Number of enrolments of both sexes of Slovak Republic?
Offer a terse response. 1.54e+07. In the year 2001, what is the difference between the Number of enrolments of both sexes in Pacific island small states and Number of enrolments of both sexes in Gabon?
Ensure brevity in your answer.  9.37e+04. In the year 2001, what is the difference between the Number of enrolments of both sexes in Pacific island small states and Number of enrolments of both sexes in Slovak Republic?
Make the answer very short. -4.69e+05. In the year 2001, what is the difference between the Number of enrolments of both sexes in Gabon and Number of enrolments of both sexes in Slovak Republic?
Ensure brevity in your answer.  -5.63e+05. In the year 2002, what is the difference between the Number of enrolments of both sexes in Fragile and conflict affected situations and Number of enrolments of both sexes in Pacific island small states?
Your response must be concise. 1.66e+07. In the year 2002, what is the difference between the Number of enrolments of both sexes of Fragile and conflict affected situations and Number of enrolments of both sexes of Gabon?
Provide a succinct answer. 1.67e+07. In the year 2002, what is the difference between the Number of enrolments of both sexes in Fragile and conflict affected situations and Number of enrolments of both sexes in Slovak Republic?
Your response must be concise. 1.61e+07. In the year 2002, what is the difference between the Number of enrolments of both sexes of Pacific island small states and Number of enrolments of both sexes of Gabon?
Your answer should be very brief. 9.81e+04. In the year 2002, what is the difference between the Number of enrolments of both sexes of Pacific island small states and Number of enrolments of both sexes of Slovak Republic?
Your answer should be very brief. -4.63e+05. In the year 2002, what is the difference between the Number of enrolments of both sexes of Gabon and Number of enrolments of both sexes of Slovak Republic?
Keep it short and to the point. -5.61e+05. What is the ratio of the Number of enrolments of both sexes in Fragile and conflict affected situations in 1994 to that in 1995?
Your answer should be compact. 0.94. What is the ratio of the Number of enrolments of both sexes in Pacific island small states in 1994 to that in 1995?
Your response must be concise. 0.98. What is the ratio of the Number of enrolments of both sexes in Gabon in 1994 to that in 1995?
Provide a succinct answer. 0.9. What is the ratio of the Number of enrolments of both sexes in Slovak Republic in 1994 to that in 1995?
Your response must be concise. 0.99. What is the ratio of the Number of enrolments of both sexes in Fragile and conflict affected situations in 1994 to that in 1996?
Make the answer very short. 0.91. What is the ratio of the Number of enrolments of both sexes of Gabon in 1994 to that in 1996?
Provide a succinct answer. 0.74. What is the ratio of the Number of enrolments of both sexes of Slovak Republic in 1994 to that in 1996?
Offer a very short reply. 0.98. What is the ratio of the Number of enrolments of both sexes in Fragile and conflict affected situations in 1994 to that in 1997?
Provide a short and direct response. 0.88. What is the ratio of the Number of enrolments of both sexes in Pacific island small states in 1994 to that in 1997?
Provide a short and direct response. 0.95. What is the ratio of the Number of enrolments of both sexes in Gabon in 1994 to that in 1997?
Give a very brief answer. 0.71. What is the ratio of the Number of enrolments of both sexes in Fragile and conflict affected situations in 1994 to that in 1999?
Ensure brevity in your answer.  0.82. What is the ratio of the Number of enrolments of both sexes in Pacific island small states in 1994 to that in 1999?
Offer a terse response. 0.92. What is the ratio of the Number of enrolments of both sexes in Gabon in 1994 to that in 1999?
Your answer should be compact. 0.69. What is the ratio of the Number of enrolments of both sexes in Fragile and conflict affected situations in 1994 to that in 2001?
Make the answer very short. 0.75. What is the ratio of the Number of enrolments of both sexes in Pacific island small states in 1994 to that in 2001?
Your response must be concise. 0.91. What is the ratio of the Number of enrolments of both sexes in Gabon in 1994 to that in 2001?
Offer a terse response. 0.59. What is the ratio of the Number of enrolments of both sexes in Fragile and conflict affected situations in 1994 to that in 2002?
Offer a very short reply. 0.71. What is the ratio of the Number of enrolments of both sexes in Pacific island small states in 1994 to that in 2002?
Give a very brief answer. 0.87. What is the ratio of the Number of enrolments of both sexes of Gabon in 1994 to that in 2002?
Your response must be concise. 0.57. What is the ratio of the Number of enrolments of both sexes in Fragile and conflict affected situations in 1995 to that in 1996?
Offer a very short reply. 0.96. What is the ratio of the Number of enrolments of both sexes of Pacific island small states in 1995 to that in 1996?
Provide a succinct answer. 0.99. What is the ratio of the Number of enrolments of both sexes in Gabon in 1995 to that in 1996?
Your response must be concise. 0.82. What is the ratio of the Number of enrolments of both sexes in Slovak Republic in 1995 to that in 1996?
Give a very brief answer. 0.99. What is the ratio of the Number of enrolments of both sexes of Fragile and conflict affected situations in 1995 to that in 1997?
Your answer should be very brief. 0.93. What is the ratio of the Number of enrolments of both sexes of Pacific island small states in 1995 to that in 1997?
Provide a short and direct response. 0.97. What is the ratio of the Number of enrolments of both sexes in Gabon in 1995 to that in 1997?
Provide a succinct answer. 0.78. What is the ratio of the Number of enrolments of both sexes in Fragile and conflict affected situations in 1995 to that in 1999?
Keep it short and to the point. 0.87. What is the ratio of the Number of enrolments of both sexes of Pacific island small states in 1995 to that in 1999?
Offer a terse response. 0.94. What is the ratio of the Number of enrolments of both sexes in Gabon in 1995 to that in 1999?
Make the answer very short. 0.76. What is the ratio of the Number of enrolments of both sexes in Slovak Republic in 1995 to that in 1999?
Your answer should be very brief. 0.98. What is the ratio of the Number of enrolments of both sexes in Fragile and conflict affected situations in 1995 to that in 2001?
Make the answer very short. 0.79. What is the ratio of the Number of enrolments of both sexes in Pacific island small states in 1995 to that in 2001?
Make the answer very short. 0.93. What is the ratio of the Number of enrolments of both sexes of Gabon in 1995 to that in 2001?
Provide a succinct answer. 0.65. What is the ratio of the Number of enrolments of both sexes in Fragile and conflict affected situations in 1995 to that in 2002?
Give a very brief answer. 0.76. What is the ratio of the Number of enrolments of both sexes of Pacific island small states in 1995 to that in 2002?
Your answer should be compact. 0.89. What is the ratio of the Number of enrolments of both sexes in Gabon in 1995 to that in 2002?
Your answer should be very brief. 0.62. What is the ratio of the Number of enrolments of both sexes of Slovak Republic in 1995 to that in 2002?
Offer a very short reply. 1. What is the ratio of the Number of enrolments of both sexes in Fragile and conflict affected situations in 1996 to that in 1997?
Ensure brevity in your answer.  0.97. What is the ratio of the Number of enrolments of both sexes in Pacific island small states in 1996 to that in 1997?
Your response must be concise. 0.99. What is the ratio of the Number of enrolments of both sexes of Gabon in 1996 to that in 1997?
Provide a short and direct response. 0.96. What is the ratio of the Number of enrolments of both sexes in Slovak Republic in 1996 to that in 1997?
Make the answer very short. 1.01. What is the ratio of the Number of enrolments of both sexes of Fragile and conflict affected situations in 1996 to that in 1999?
Offer a terse response. 0.9. What is the ratio of the Number of enrolments of both sexes in Pacific island small states in 1996 to that in 1999?
Provide a succinct answer. 0.95. What is the ratio of the Number of enrolments of both sexes in Gabon in 1996 to that in 1999?
Your answer should be very brief. 0.93. What is the ratio of the Number of enrolments of both sexes of Fragile and conflict affected situations in 1996 to that in 2001?
Offer a terse response. 0.82. What is the ratio of the Number of enrolments of both sexes of Pacific island small states in 1996 to that in 2001?
Provide a short and direct response. 0.94. What is the ratio of the Number of enrolments of both sexes of Gabon in 1996 to that in 2001?
Offer a very short reply. 0.8. What is the ratio of the Number of enrolments of both sexes of Slovak Republic in 1996 to that in 2001?
Your answer should be compact. 1.01. What is the ratio of the Number of enrolments of both sexes in Fragile and conflict affected situations in 1996 to that in 2002?
Your response must be concise. 0.78. What is the ratio of the Number of enrolments of both sexes of Pacific island small states in 1996 to that in 2002?
Make the answer very short. 0.9. What is the ratio of the Number of enrolments of both sexes of Gabon in 1996 to that in 2002?
Your response must be concise. 0.77. What is the ratio of the Number of enrolments of both sexes in Slovak Republic in 1996 to that in 2002?
Offer a very short reply. 1.01. What is the ratio of the Number of enrolments of both sexes of Fragile and conflict affected situations in 1997 to that in 1999?
Provide a succinct answer. 0.93. What is the ratio of the Number of enrolments of both sexes in Pacific island small states in 1997 to that in 1999?
Give a very brief answer. 0.96. What is the ratio of the Number of enrolments of both sexes in Gabon in 1997 to that in 1999?
Your response must be concise. 0.97. What is the ratio of the Number of enrolments of both sexes in Slovak Republic in 1997 to that in 1999?
Provide a short and direct response. 0.98. What is the ratio of the Number of enrolments of both sexes of Fragile and conflict affected situations in 1997 to that in 2001?
Ensure brevity in your answer.  0.85. What is the ratio of the Number of enrolments of both sexes of Pacific island small states in 1997 to that in 2001?
Your response must be concise. 0.95. What is the ratio of the Number of enrolments of both sexes in Gabon in 1997 to that in 2001?
Provide a short and direct response. 0.84. What is the ratio of the Number of enrolments of both sexes of Fragile and conflict affected situations in 1997 to that in 2002?
Make the answer very short. 0.81. What is the ratio of the Number of enrolments of both sexes in Pacific island small states in 1997 to that in 2002?
Provide a succinct answer. 0.91. What is the ratio of the Number of enrolments of both sexes of Gabon in 1997 to that in 2002?
Provide a short and direct response. 0.8. What is the ratio of the Number of enrolments of both sexes of Slovak Republic in 1997 to that in 2002?
Make the answer very short. 0.99. What is the ratio of the Number of enrolments of both sexes of Fragile and conflict affected situations in 1999 to that in 2001?
Offer a terse response. 0.91. What is the ratio of the Number of enrolments of both sexes of Pacific island small states in 1999 to that in 2001?
Provide a succinct answer. 0.99. What is the ratio of the Number of enrolments of both sexes of Gabon in 1999 to that in 2001?
Give a very brief answer. 0.86. What is the ratio of the Number of enrolments of both sexes of Slovak Republic in 1999 to that in 2001?
Provide a short and direct response. 1.02. What is the ratio of the Number of enrolments of both sexes of Fragile and conflict affected situations in 1999 to that in 2002?
Ensure brevity in your answer.  0.87. What is the ratio of the Number of enrolments of both sexes in Pacific island small states in 1999 to that in 2002?
Provide a succinct answer. 0.95. What is the ratio of the Number of enrolments of both sexes of Gabon in 1999 to that in 2002?
Offer a very short reply. 0.82. What is the ratio of the Number of enrolments of both sexes in Slovak Republic in 1999 to that in 2002?
Make the answer very short. 1.01. What is the ratio of the Number of enrolments of both sexes in Fragile and conflict affected situations in 2001 to that in 2002?
Your response must be concise. 0.96. What is the ratio of the Number of enrolments of both sexes in Pacific island small states in 2001 to that in 2002?
Ensure brevity in your answer.  0.96. What is the ratio of the Number of enrolments of both sexes of Gabon in 2001 to that in 2002?
Your answer should be compact. 0.96. What is the difference between the highest and the second highest Number of enrolments of both sexes in Fragile and conflict affected situations?
Keep it short and to the point. 7.44e+05. What is the difference between the highest and the second highest Number of enrolments of both sexes of Pacific island small states?
Keep it short and to the point. 8784.14. What is the difference between the highest and the second highest Number of enrolments of both sexes of Gabon?
Give a very brief answer. 4473. What is the difference between the highest and the second highest Number of enrolments of both sexes of Slovak Republic?
Your answer should be very brief. 4507. What is the difference between the highest and the lowest Number of enrolments of both sexes in Fragile and conflict affected situations?
Your response must be concise. 4.82e+06. What is the difference between the highest and the lowest Number of enrolments of both sexes in Pacific island small states?
Your response must be concise. 2.68e+04. What is the difference between the highest and the lowest Number of enrolments of both sexes in Gabon?
Offer a very short reply. 4.57e+04. What is the difference between the highest and the lowest Number of enrolments of both sexes in Slovak Republic?
Ensure brevity in your answer.  1.62e+04. 